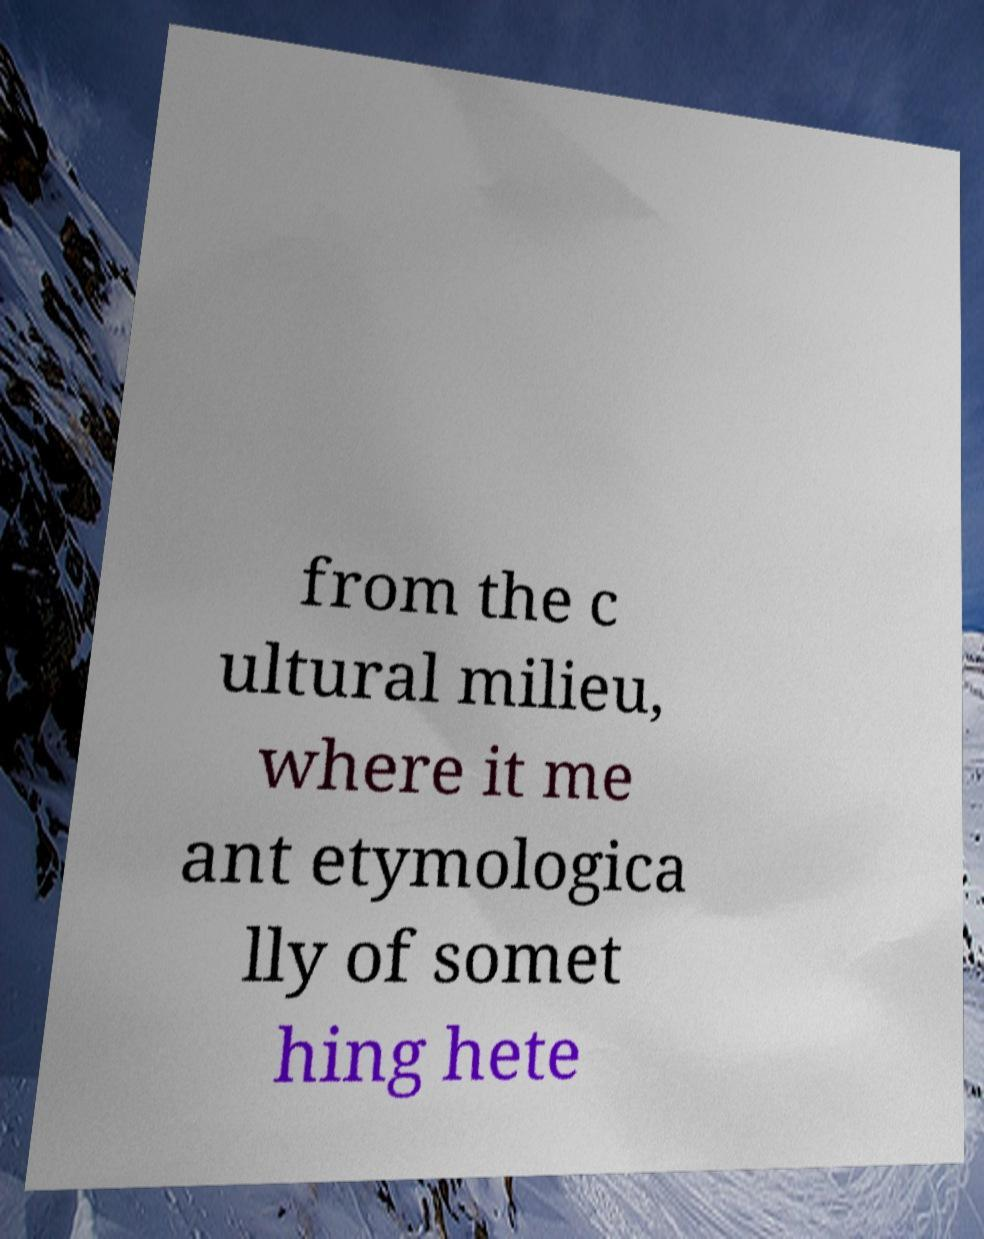Can you accurately transcribe the text from the provided image for me? from the c ultural milieu, where it me ant etymologica lly of somet hing hete 